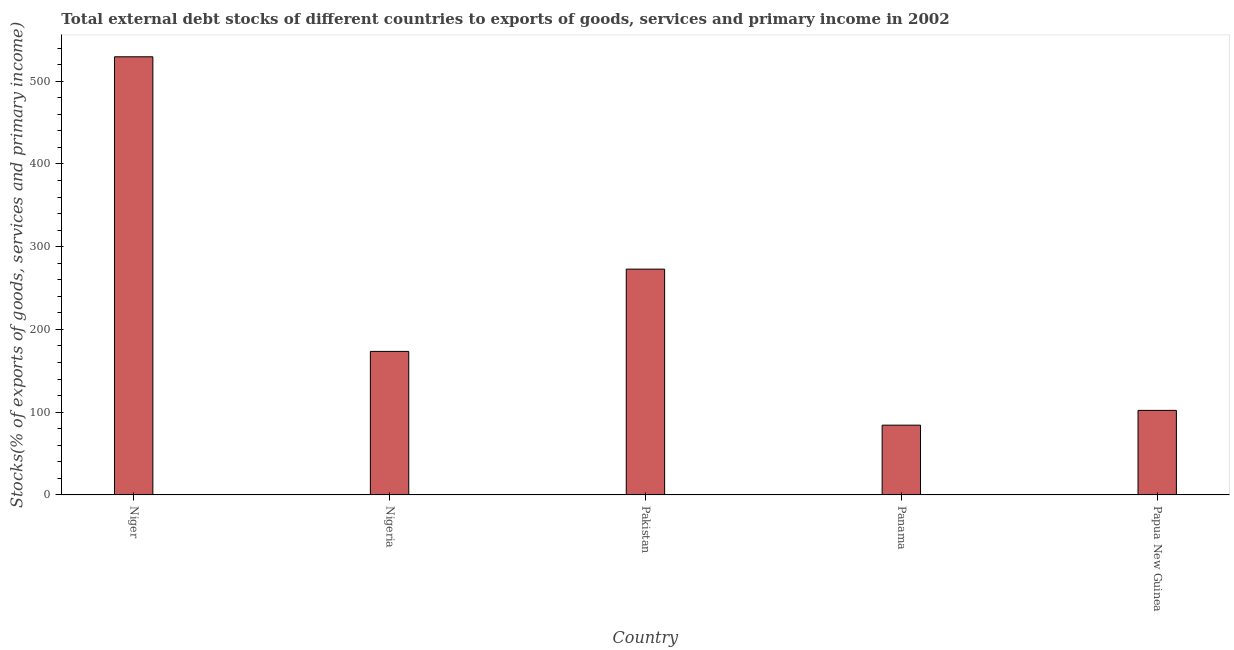Does the graph contain any zero values?
Provide a short and direct response. No. Does the graph contain grids?
Provide a short and direct response. No. What is the title of the graph?
Provide a short and direct response. Total external debt stocks of different countries to exports of goods, services and primary income in 2002. What is the label or title of the X-axis?
Your answer should be very brief. Country. What is the label or title of the Y-axis?
Give a very brief answer. Stocks(% of exports of goods, services and primary income). What is the external debt stocks in Nigeria?
Ensure brevity in your answer.  173.47. Across all countries, what is the maximum external debt stocks?
Make the answer very short. 529.5. Across all countries, what is the minimum external debt stocks?
Make the answer very short. 84.32. In which country was the external debt stocks maximum?
Make the answer very short. Niger. In which country was the external debt stocks minimum?
Provide a succinct answer. Panama. What is the sum of the external debt stocks?
Offer a very short reply. 1162.34. What is the difference between the external debt stocks in Nigeria and Papua New Guinea?
Ensure brevity in your answer.  71.29. What is the average external debt stocks per country?
Your response must be concise. 232.47. What is the median external debt stocks?
Your answer should be very brief. 173.47. What is the ratio of the external debt stocks in Pakistan to that in Panama?
Offer a very short reply. 3.24. Is the external debt stocks in Niger less than that in Nigeria?
Offer a terse response. No. What is the difference between the highest and the second highest external debt stocks?
Your answer should be very brief. 256.62. What is the difference between the highest and the lowest external debt stocks?
Your answer should be compact. 445.18. In how many countries, is the external debt stocks greater than the average external debt stocks taken over all countries?
Offer a very short reply. 2. How many bars are there?
Ensure brevity in your answer.  5. Are the values on the major ticks of Y-axis written in scientific E-notation?
Keep it short and to the point. No. What is the Stocks(% of exports of goods, services and primary income) in Niger?
Your answer should be compact. 529.5. What is the Stocks(% of exports of goods, services and primary income) of Nigeria?
Keep it short and to the point. 173.47. What is the Stocks(% of exports of goods, services and primary income) of Pakistan?
Make the answer very short. 272.88. What is the Stocks(% of exports of goods, services and primary income) of Panama?
Offer a very short reply. 84.32. What is the Stocks(% of exports of goods, services and primary income) in Papua New Guinea?
Your answer should be very brief. 102.18. What is the difference between the Stocks(% of exports of goods, services and primary income) in Niger and Nigeria?
Offer a very short reply. 356.03. What is the difference between the Stocks(% of exports of goods, services and primary income) in Niger and Pakistan?
Give a very brief answer. 256.62. What is the difference between the Stocks(% of exports of goods, services and primary income) in Niger and Panama?
Keep it short and to the point. 445.18. What is the difference between the Stocks(% of exports of goods, services and primary income) in Niger and Papua New Guinea?
Your response must be concise. 427.32. What is the difference between the Stocks(% of exports of goods, services and primary income) in Nigeria and Pakistan?
Keep it short and to the point. -99.41. What is the difference between the Stocks(% of exports of goods, services and primary income) in Nigeria and Panama?
Make the answer very short. 89.14. What is the difference between the Stocks(% of exports of goods, services and primary income) in Nigeria and Papua New Guinea?
Provide a short and direct response. 71.29. What is the difference between the Stocks(% of exports of goods, services and primary income) in Pakistan and Panama?
Your answer should be very brief. 188.56. What is the difference between the Stocks(% of exports of goods, services and primary income) in Pakistan and Papua New Guinea?
Provide a short and direct response. 170.7. What is the difference between the Stocks(% of exports of goods, services and primary income) in Panama and Papua New Guinea?
Give a very brief answer. -17.86. What is the ratio of the Stocks(% of exports of goods, services and primary income) in Niger to that in Nigeria?
Your response must be concise. 3.05. What is the ratio of the Stocks(% of exports of goods, services and primary income) in Niger to that in Pakistan?
Offer a terse response. 1.94. What is the ratio of the Stocks(% of exports of goods, services and primary income) in Niger to that in Panama?
Your answer should be very brief. 6.28. What is the ratio of the Stocks(% of exports of goods, services and primary income) in Niger to that in Papua New Guinea?
Your response must be concise. 5.18. What is the ratio of the Stocks(% of exports of goods, services and primary income) in Nigeria to that in Pakistan?
Ensure brevity in your answer.  0.64. What is the ratio of the Stocks(% of exports of goods, services and primary income) in Nigeria to that in Panama?
Your answer should be very brief. 2.06. What is the ratio of the Stocks(% of exports of goods, services and primary income) in Nigeria to that in Papua New Guinea?
Ensure brevity in your answer.  1.7. What is the ratio of the Stocks(% of exports of goods, services and primary income) in Pakistan to that in Panama?
Provide a short and direct response. 3.24. What is the ratio of the Stocks(% of exports of goods, services and primary income) in Pakistan to that in Papua New Guinea?
Offer a terse response. 2.67. What is the ratio of the Stocks(% of exports of goods, services and primary income) in Panama to that in Papua New Guinea?
Your response must be concise. 0.82. 